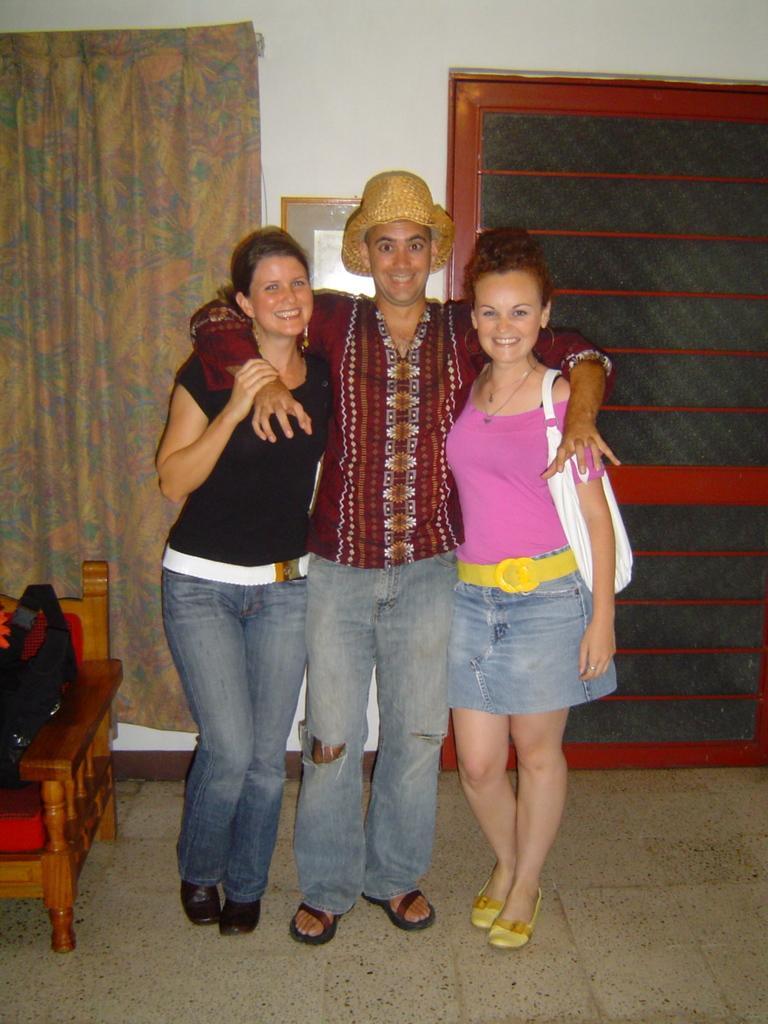Could you give a brief overview of what you see in this image? In this picture we can see a man and two women standing on the floor and smiling, chair and in the background we can see a curtain, frame on the wall. 